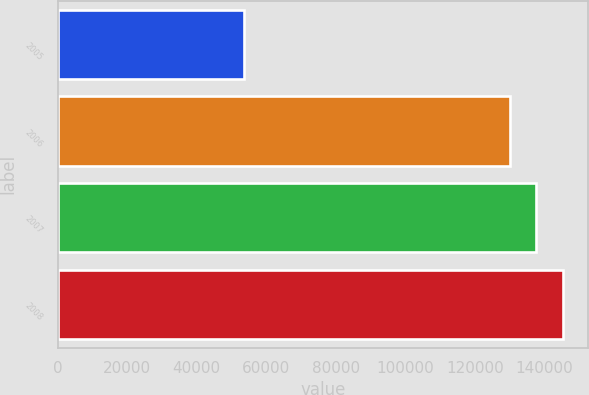Convert chart to OTSL. <chart><loc_0><loc_0><loc_500><loc_500><bar_chart><fcel>2005<fcel>2006<fcel>2007<fcel>2008<nl><fcel>53699<fcel>130000<fcel>137630<fcel>145260<nl></chart> 